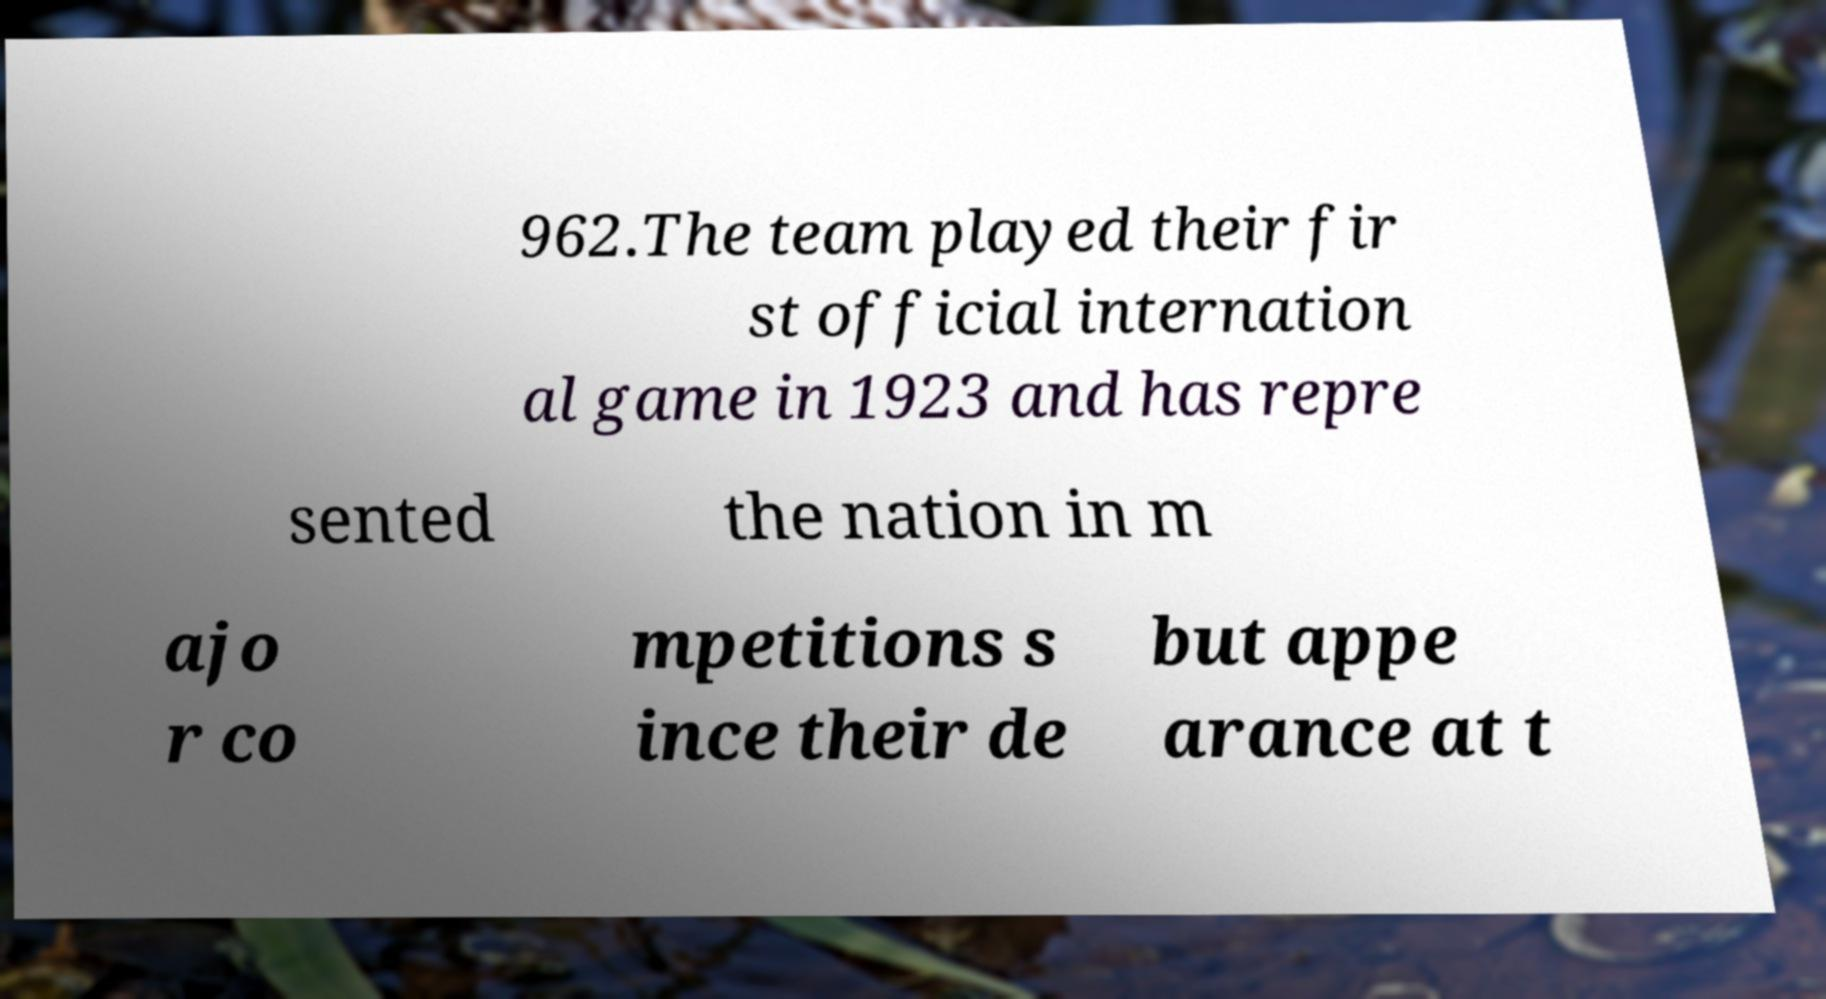Please read and relay the text visible in this image. What does it say? 962.The team played their fir st official internation al game in 1923 and has repre sented the nation in m ajo r co mpetitions s ince their de but appe arance at t 